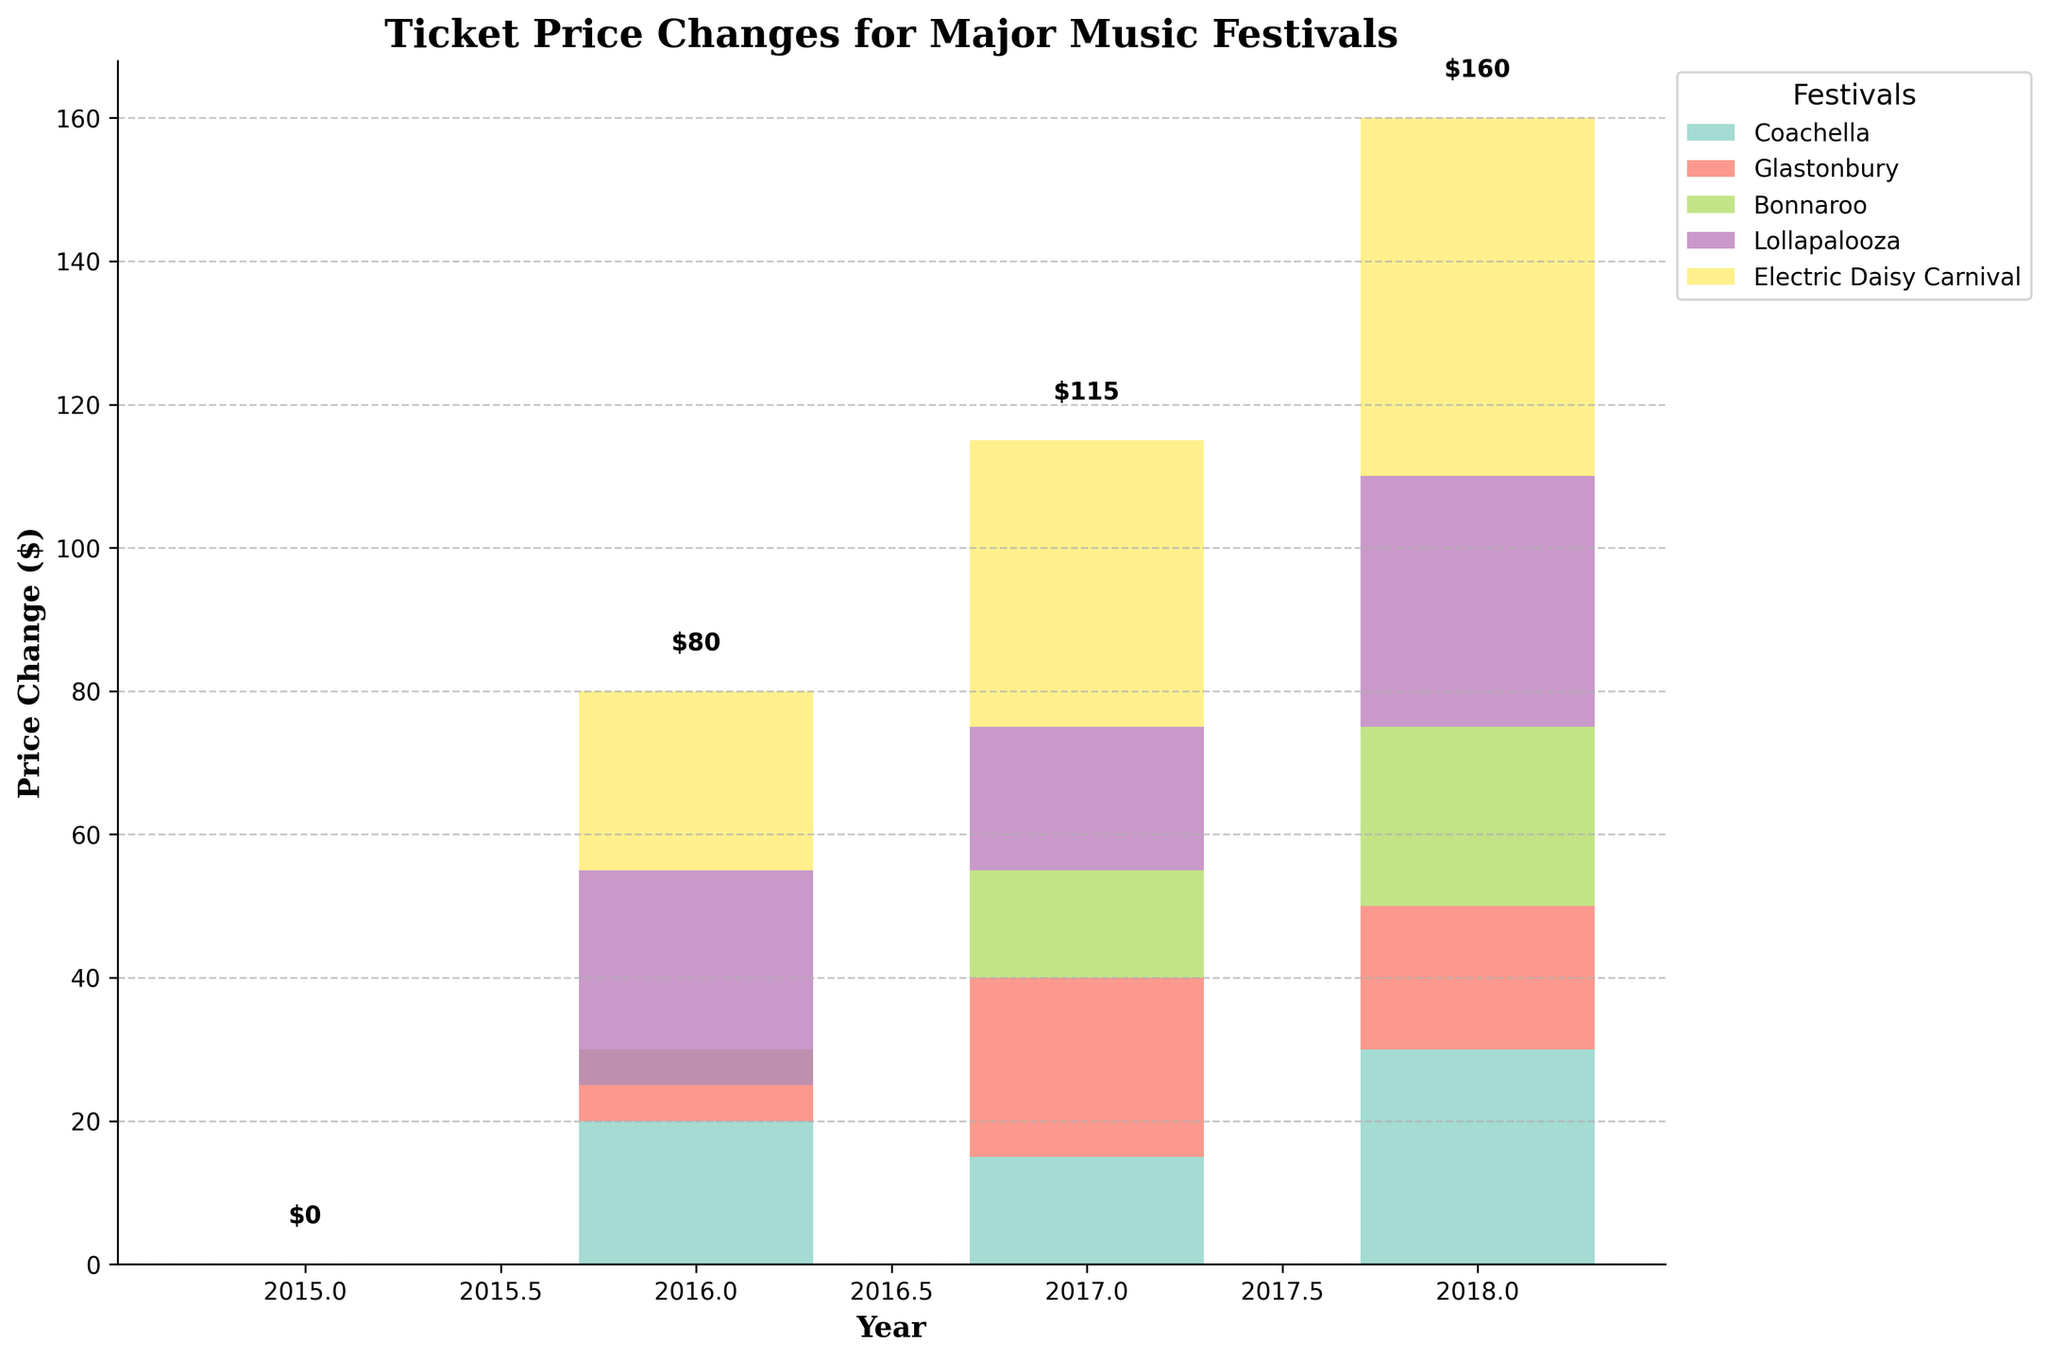What's the title of the chart? The title is displayed at the top of the chart. Reading it provides the context of the chart.
Answer: "Ticket Price Changes for Major Music Festivals" Which festival had the largest price increase in 2018? The largest price increase in 2018 can be determined by looking at the top values on the y-axis for the year 2018. Electric Daisy Carnival shows the largest increase.
Answer: Electric Daisy Carnival How much did the ticket price for Bonnaroo change in 2016? To find the price change for Bonnaroo in 2016, locate the bar corresponding to Bonnaroo in that year and read the change value. The bar extends slightly below the x-axis, indicating a decrease.
Answer: -$5 Compare the price changes for Coachella and Glastonbury in 2017. Which one was higher? Look at the heights of the bars for Coachella and Glastonbury in 2017. Glastonbury’s bar is taller.
Answer: Glastonbury What is the cumulative price change for Electric Daisy Carnival from 2015 to 2018? Sum the price changes for each year for Electric Daisy Carnival: 0 + 25 + 40 + 50.
Answer: $115 Which festival experienced a price decrease in any of the years shown? Identify any bars that extend below the x-axis. Bonnaroo's bar in 2016 extends below the x-axis, indicating a price decrease.
Answer: Bonnaroo How does the ticket price change for Lollapalooza in 2016 compare to Coachella in 2016? Compare the bar heights for both festivals in 2016. Lollapalooza had a higher increase, evident from its higher bar.
Answer: Lollapalooza had a higher increase What's the total price change for Glastonbury from 2015 to 2018? Sum the price changes from each year for Glastonbury: 0 + 10 + 25 + 20.
Answer: $55 